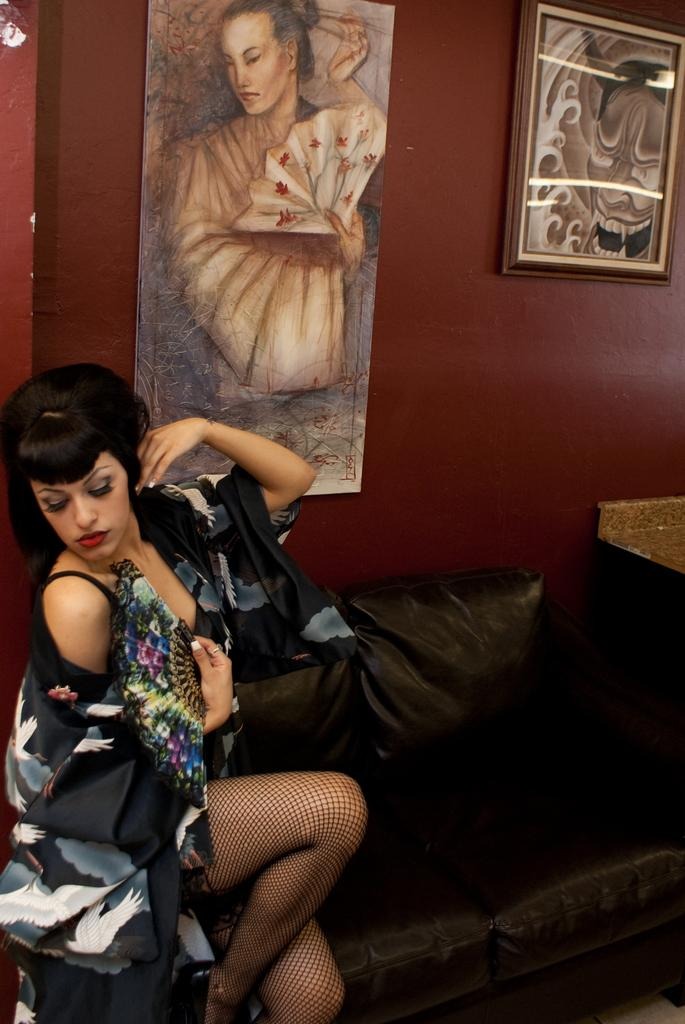Who is present in the image? There is a woman in the image. What is the woman doing in the image? The woman is sitting on a couch. What object is the woman holding in the image? The woman is holding a hand fan. What can be seen behind the woman in the image? There is a wall behind the woman. What decorative items are on the wall? There are picture frames on the wall. What type of copper material is used to make the gate in the image? There is no gate present in the image, and therefore no copper material can be observed. Is the tramp performing any tricks in the image? There is no tramp present in the image, so no tricks can be observed. 